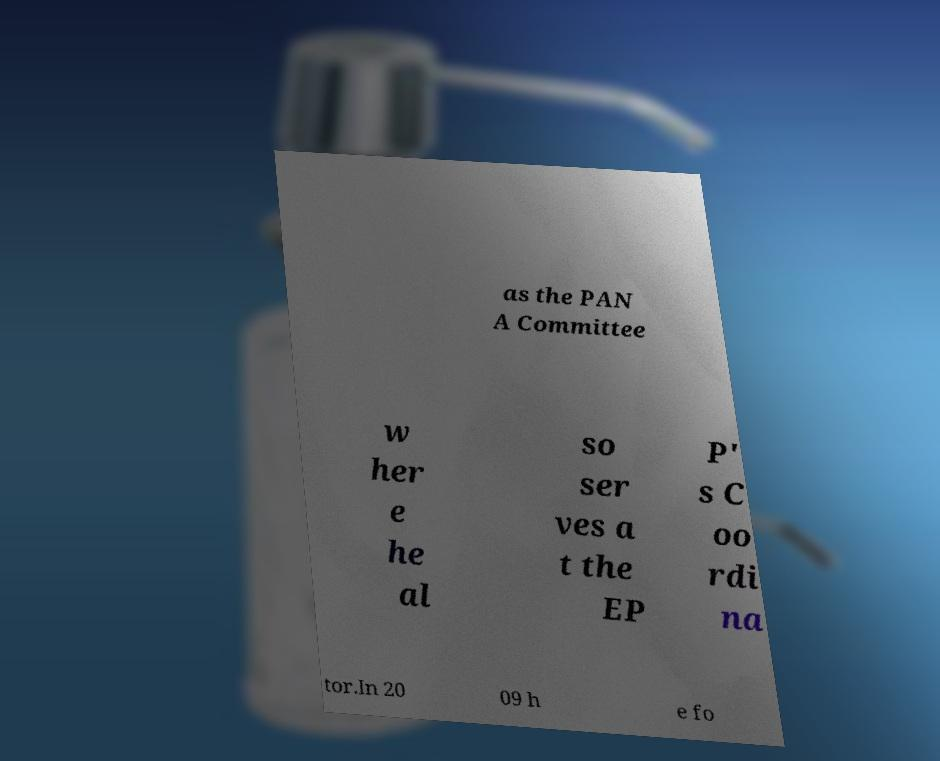What messages or text are displayed in this image? I need them in a readable, typed format. as the PAN A Committee w her e he al so ser ves a t the EP P' s C oo rdi na tor.In 20 09 h e fo 